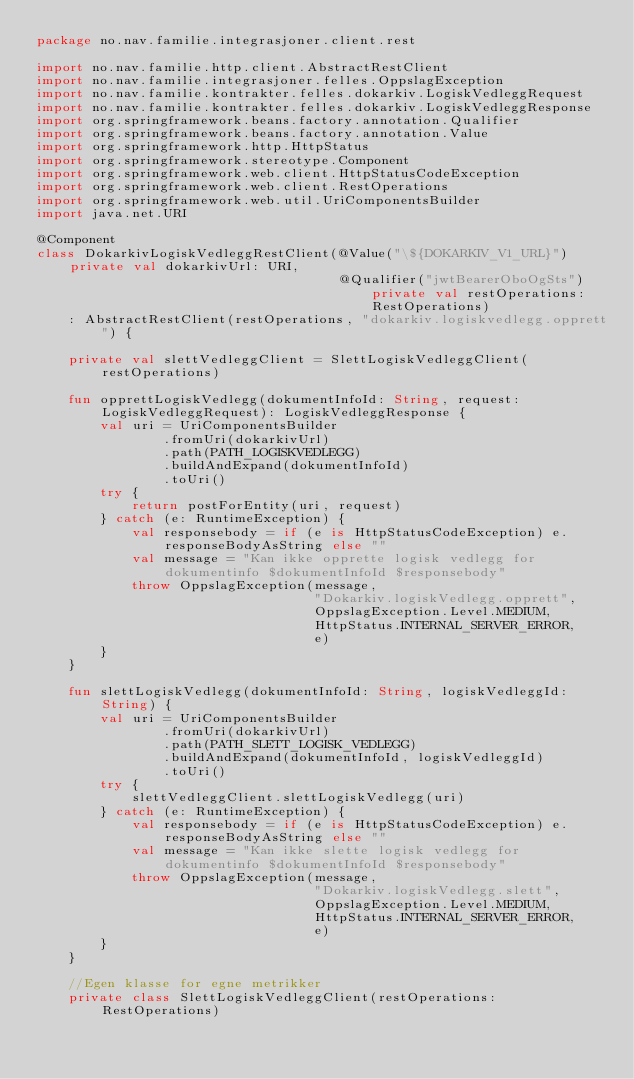Convert code to text. <code><loc_0><loc_0><loc_500><loc_500><_Kotlin_>package no.nav.familie.integrasjoner.client.rest

import no.nav.familie.http.client.AbstractRestClient
import no.nav.familie.integrasjoner.felles.OppslagException
import no.nav.familie.kontrakter.felles.dokarkiv.LogiskVedleggRequest
import no.nav.familie.kontrakter.felles.dokarkiv.LogiskVedleggResponse
import org.springframework.beans.factory.annotation.Qualifier
import org.springframework.beans.factory.annotation.Value
import org.springframework.http.HttpStatus
import org.springframework.stereotype.Component
import org.springframework.web.client.HttpStatusCodeException
import org.springframework.web.client.RestOperations
import org.springframework.web.util.UriComponentsBuilder
import java.net.URI

@Component
class DokarkivLogiskVedleggRestClient(@Value("\${DOKARKIV_V1_URL}") private val dokarkivUrl: URI,
                                      @Qualifier("jwtBearerOboOgSts") private val restOperations: RestOperations)
    : AbstractRestClient(restOperations, "dokarkiv.logiskvedlegg.opprett") {

    private val slettVedleggClient = SlettLogiskVedleggClient(restOperations)

    fun opprettLogiskVedlegg(dokumentInfoId: String, request: LogiskVedleggRequest): LogiskVedleggResponse {
        val uri = UriComponentsBuilder
                .fromUri(dokarkivUrl)
                .path(PATH_LOGISKVEDLEGG)
                .buildAndExpand(dokumentInfoId)
                .toUri()
        try {
            return postForEntity(uri, request)
        } catch (e: RuntimeException) {
            val responsebody = if (e is HttpStatusCodeException) e.responseBodyAsString else ""
            val message = "Kan ikke opprette logisk vedlegg for dokumentinfo $dokumentInfoId $responsebody"
            throw OppslagException(message,
                                   "Dokarkiv.logiskVedlegg.opprett",
                                   OppslagException.Level.MEDIUM,
                                   HttpStatus.INTERNAL_SERVER_ERROR,
                                   e)
        }
    }

    fun slettLogiskVedlegg(dokumentInfoId: String, logiskVedleggId: String) {
        val uri = UriComponentsBuilder
                .fromUri(dokarkivUrl)
                .path(PATH_SLETT_LOGISK_VEDLEGG)
                .buildAndExpand(dokumentInfoId, logiskVedleggId)
                .toUri()
        try {
            slettVedleggClient.slettLogiskVedlegg(uri)
        } catch (e: RuntimeException) {
            val responsebody = if (e is HttpStatusCodeException) e.responseBodyAsString else ""
            val message = "Kan ikke slette logisk vedlegg for dokumentinfo $dokumentInfoId $responsebody"
            throw OppslagException(message,
                                   "Dokarkiv.logiskVedlegg.slett",
                                   OppslagException.Level.MEDIUM,
                                   HttpStatus.INTERNAL_SERVER_ERROR,
                                   e)
        }
    }

    //Egen klasse for egne metrikker
    private class SlettLogiskVedleggClient(restOperations: RestOperations)</code> 